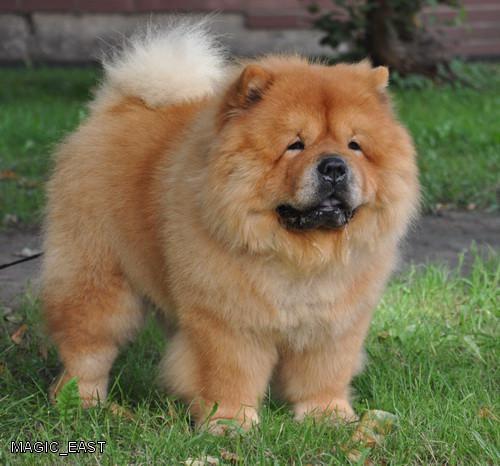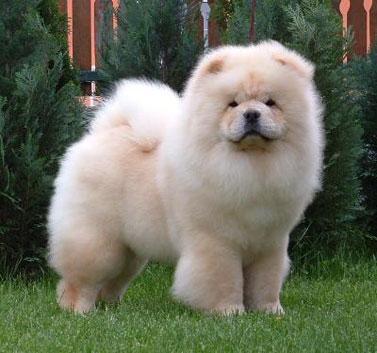The first image is the image on the left, the second image is the image on the right. For the images shown, is this caption "One image contains exactly two look-alike chow pups on green grass." true? Answer yes or no. No. The first image is the image on the left, the second image is the image on the right. Considering the images on both sides, is "There are two Chow Chows." valid? Answer yes or no. Yes. 